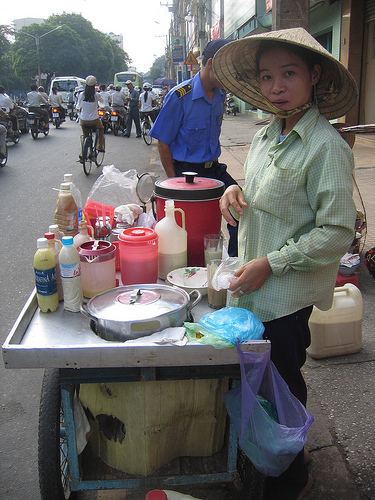<image>
Is there a bus in front of the car? Yes. The bus is positioned in front of the car, appearing closer to the camera viewpoint. 